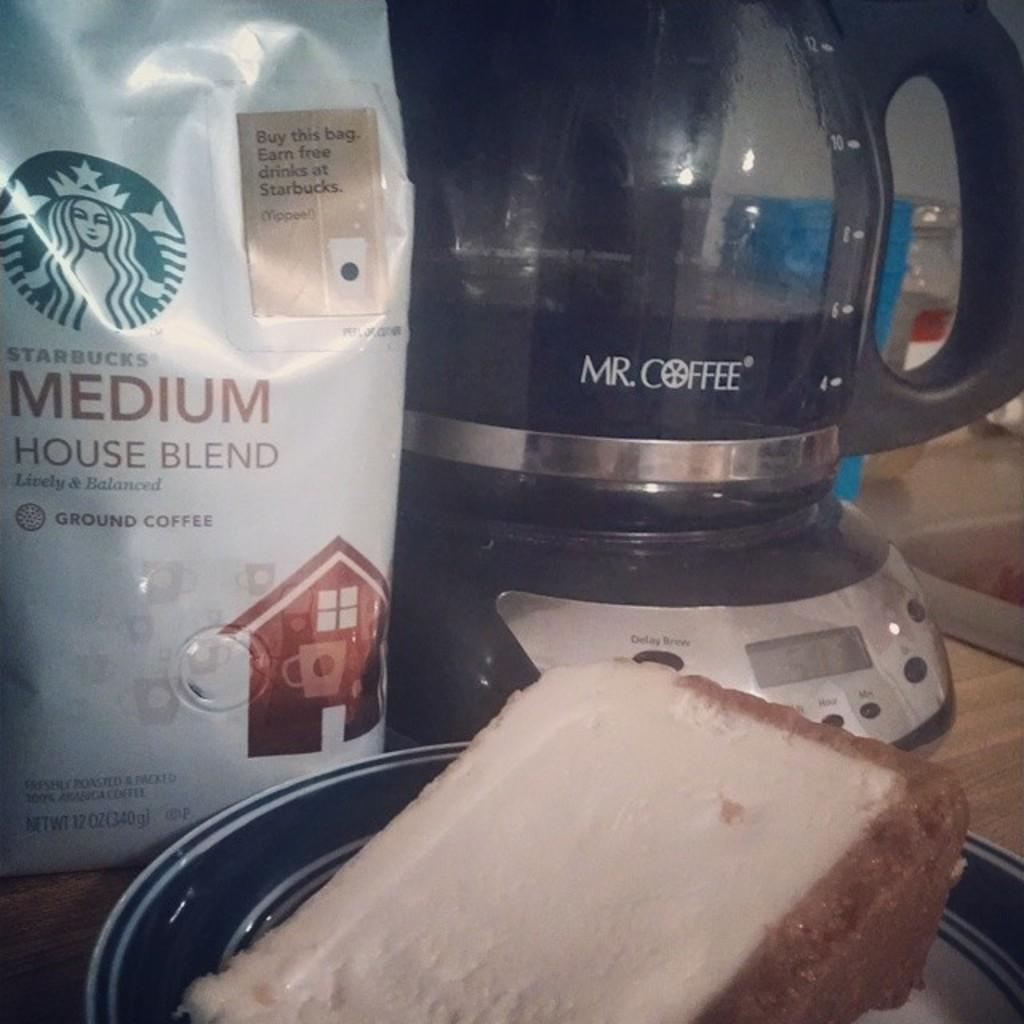<image>
Offer a succinct explanation of the picture presented. some coffee and a coffee maker by Mr Coffee on the table with a piece of cake. 